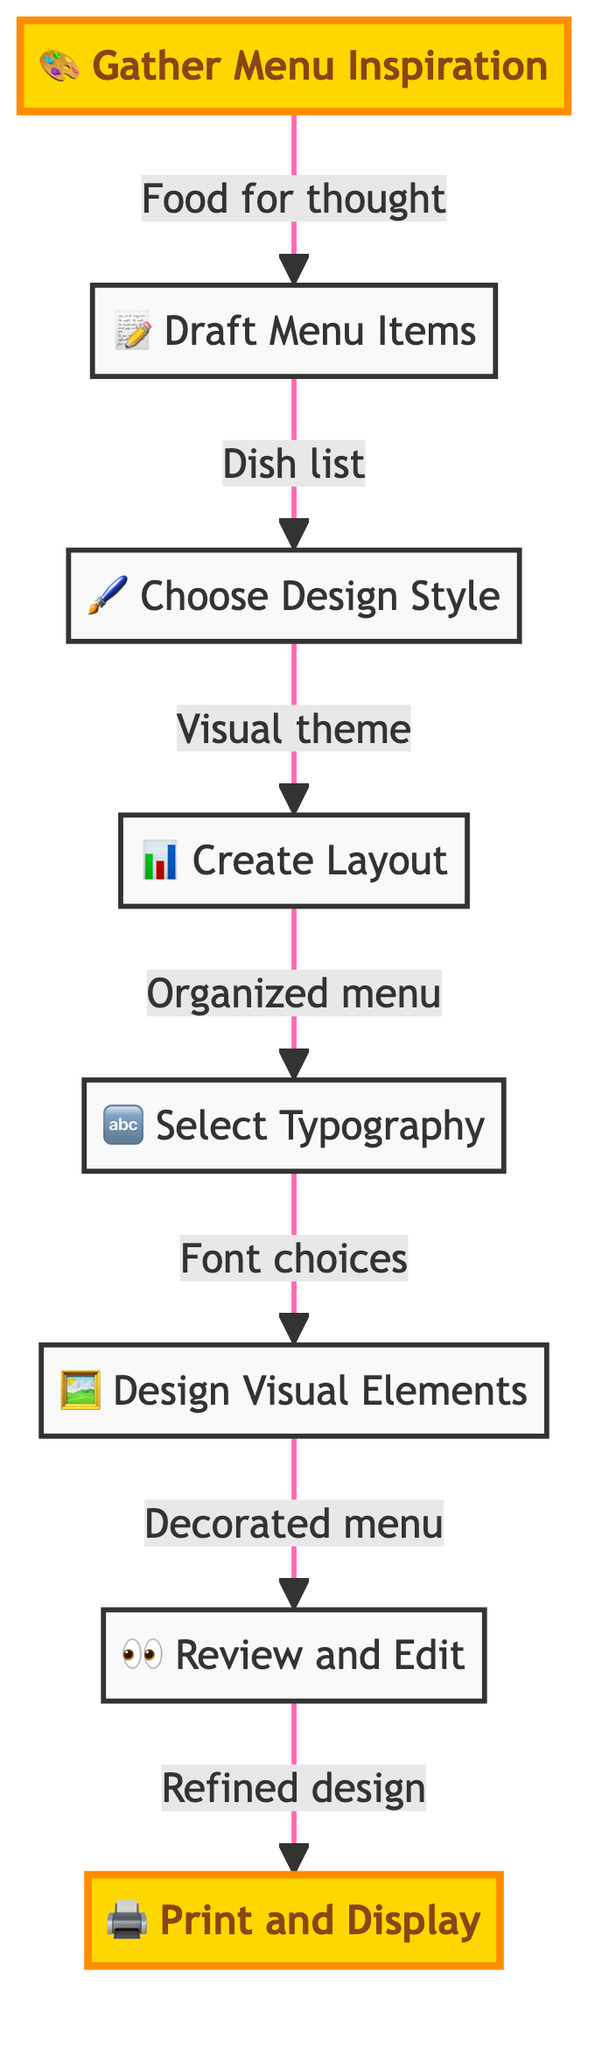What is the first step in the menu design workflow? The first step in the workflow, as indicated by the diagram, is "Gather Menu Inspiration". This is the initial node that starts the flow of the entire process.
Answer: Gather Menu Inspiration How many total steps are there in the menu design workflow? By counting the nodes in the diagram, we see there are a total of eight steps depicted in the workflow.
Answer: Eight What is the final step of the workflow? The final step indicated in the flowchart is "Print and Display", which concludes the menu design process.
Answer: Print and Display Which step follows "Draft Menu Items"? The diagram shows that after "Draft Menu Items", the next step is "Choose Design Style", indicating a sequential progression from listing items to determining the aesthetic direction.
Answer: Choose Design Style What visual element is used to represent the "Review and Edit" step? In the diagram, the "Review and Edit" step is represented with an eye emoji (👀), symbolizing scrutiny and assessment of the design.
Answer: 👀 How does one transition from "Select Typography" to the next step? Transitioning from "Select Typography" to "Design Visual Elements" is indicated by an arrow directed from the typography step to the visual elements step, showing a clear flow in the process.
Answer: Through an arrow What is the relationship between "Create Layout" and "Select Typography"? The flowchart illustrates a sequential relationship where "Create Layout" precedes "Select Typography", meaning the layout is determined before selecting the appropriate fonts.
Answer: Sequential Which step is highlighted in the diagram? The steps "Gather Menu Inspiration" and "Print and Display" are highlighted, signifying their importance in the workflow process.
Answer: Gather Menu Inspiration, Print and Display Identify two actions that happen after "Design Visual Elements". The actions that occur after "Design Visual Elements" are "Review and Edit" followed by "Print and Display", indicating a review phase and then final presentation.
Answer: Review and Edit, Print and Display 